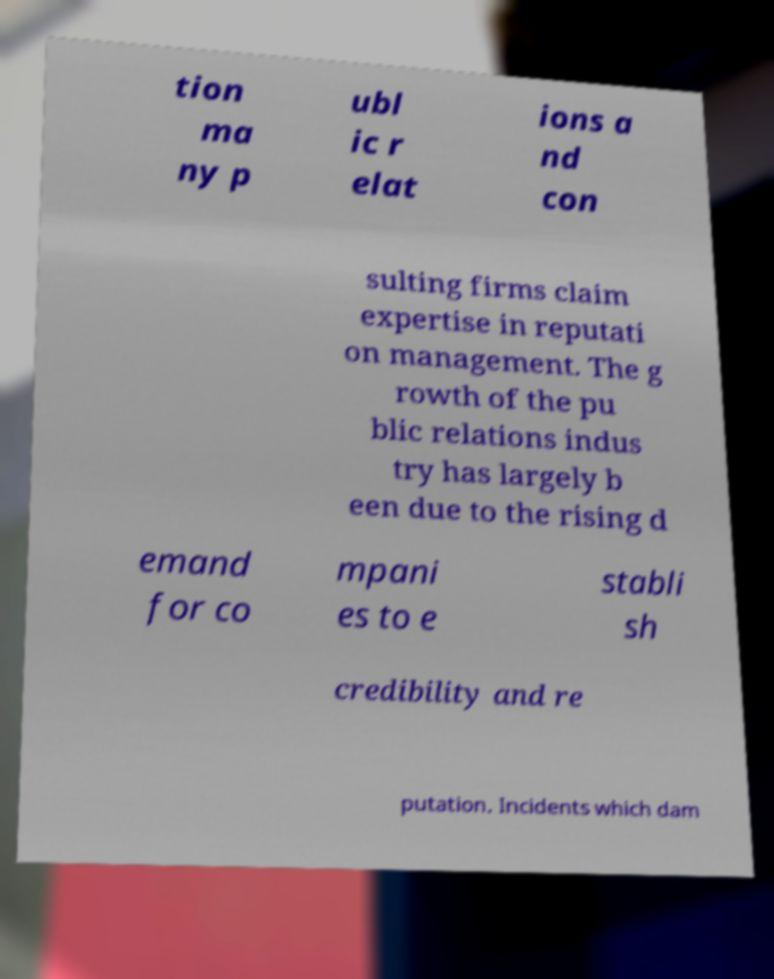Could you assist in decoding the text presented in this image and type it out clearly? tion ma ny p ubl ic r elat ions a nd con sulting firms claim expertise in reputati on management. The g rowth of the pu blic relations indus try has largely b een due to the rising d emand for co mpani es to e stabli sh credibility and re putation. Incidents which dam 